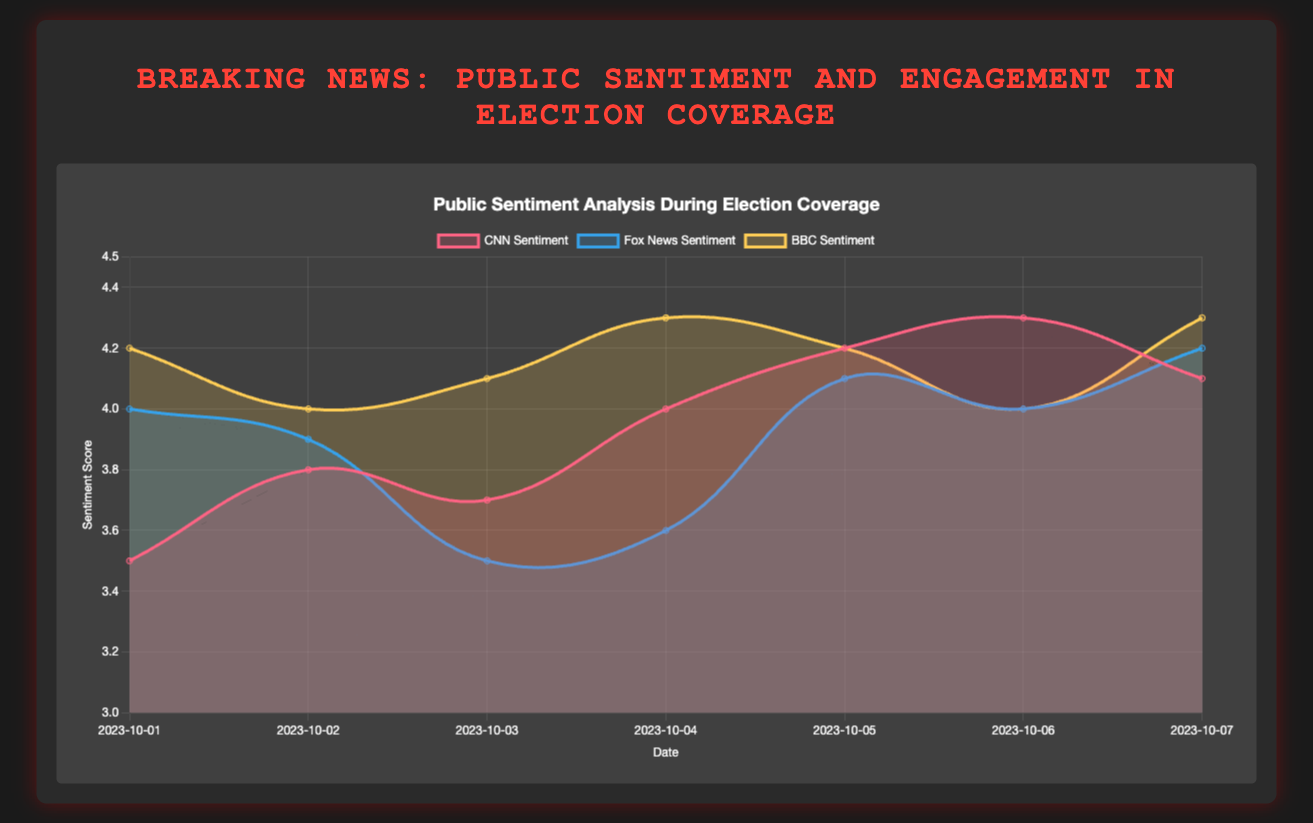What is the title of the chart? The title is the textual element located at the top of the chart, providing an overview of what the chart represents.
Answer: Breaking News: Public Sentiment and Engagement in Election Coverage What does the y-axis represent in the chart? The y-axis shows the variable measured on the vertical scale, specifying the range and units of the values. In this case, it represents the sentiment score.
Answer: Sentiment Score How many dates does the chart cover? The dates can be counted by examining the x-axis labels, which indicate the range of dates included in the chart.
Answer: Seven Which news channel has the highest sentiment on October 5? To determine this, look at the data points for October 5 and compare the sentiment scores for CNN, Fox News, and BBC.
Answer: CNN with a sentiment score of 4.2 What is the general trend of CNN sentiment scores over the dates? By observing the line and area representing CNN sentiment scores, note the changes in values across dates to identify an increasing, decreasing, or stable trend.
Answer: Increasing On which date did BBC have the highest engagement level? Check the engagement values for BBC across all dates and identify which date has BBC's highest engagement score.
Answer: October 5 How does Fox News sentiment on October 3 compare to CNN sentiment on the same date? Find the sentiment scores for both news channels on October 3 and compare them to see if one is higher, lower, or equal to the other.
Answer: Fox News has a lower sentiment (3.5 vs. 3.7) What is the average sentiment score for CNN for the given dates? Add up the CNN sentiment scores for all dates and divide by the number of dates (7) to get the average. The sum is 3.5 + 3.8 + 3.7 + 4.0 + 4.2 + 4.3 + 4.1, which equals 27.6. Dividing by 7, the average is 3.94.
Answer: 3.94 Which news channel shows the lowest engagement on any date and what is that value? By examining the engagement levels for each news channel across all dates, identify the minimum value observed.
Answer: Fox News on October 2 with 1250 